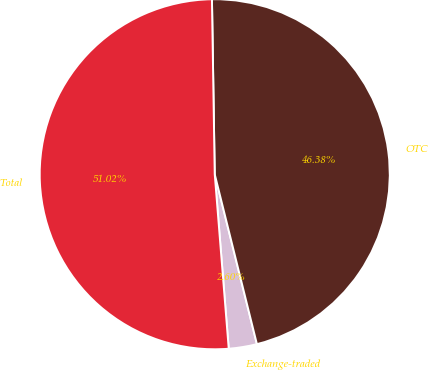Convert chart. <chart><loc_0><loc_0><loc_500><loc_500><pie_chart><fcel>Exchange-traded<fcel>OTC<fcel>Total<nl><fcel>2.6%<fcel>46.38%<fcel>51.02%<nl></chart> 